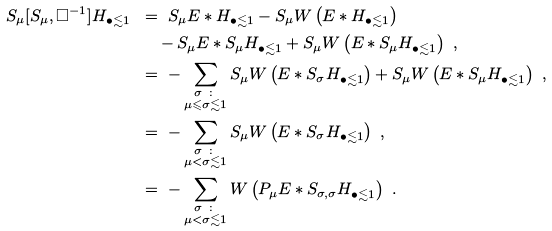<formula> <loc_0><loc_0><loc_500><loc_500>S _ { \mu } [ S _ { \mu } , \Box ^ { - 1 } ] H _ { \bullet \lesssim 1 } \ & = \ S _ { \mu } E * H _ { \bullet \lesssim 1 } - S _ { \mu } W \left ( E * H _ { \bullet \lesssim 1 } \right ) \\ & \quad - S _ { \mu } E * S _ { \mu } H _ { \bullet \lesssim 1 } + S _ { \mu } W \left ( E * S _ { \mu } H _ { \bullet \lesssim 1 } \right ) \ , \\ & = \ - \sum _ { \substack { \sigma \ \colon \\ \mu \leqslant \sigma \lesssim 1 } } S _ { \mu } W \left ( E * S _ { \sigma } H _ { \bullet \lesssim 1 } \right ) + S _ { \mu } W \left ( E * S _ { \mu } H _ { \bullet \lesssim 1 } \right ) \ , \\ & = \ - \sum _ { \substack { \sigma \ \colon \\ \mu < \sigma \lesssim 1 } } S _ { \mu } W \left ( E * S _ { \sigma } H _ { \bullet \lesssim 1 } \right ) \ , \\ & = \ - \sum _ { \substack { \sigma \ \colon \\ \mu < \sigma \lesssim 1 } } W \left ( P _ { \mu } E * S _ { \sigma , \sigma } H _ { \bullet \lesssim 1 } \right ) \ .</formula> 